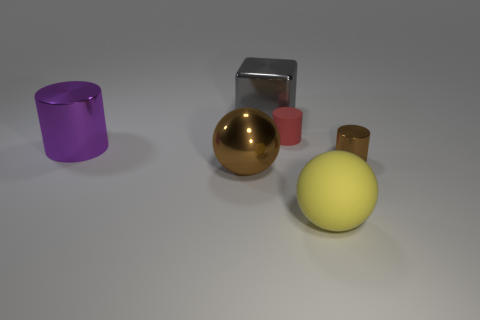There is a brown thing to the right of the big sphere on the right side of the big ball that is to the left of the gray cube; what shape is it?
Give a very brief answer. Cylinder. What material is the big purple object?
Provide a succinct answer. Metal. What is the color of the big cylinder that is made of the same material as the gray object?
Provide a succinct answer. Purple. There is a metal cylinder that is in front of the big metallic cylinder; is there a small shiny thing in front of it?
Your answer should be very brief. No. What number of other objects are the same shape as the red object?
Provide a short and direct response. 2. There is a brown thing in front of the small metallic cylinder; does it have the same shape as the brown metallic object that is on the right side of the large cube?
Provide a succinct answer. No. What number of matte spheres are in front of the matte thing that is in front of the cylinder in front of the purple thing?
Your response must be concise. 0. What is the color of the big shiny block?
Your answer should be very brief. Gray. How many other things are there of the same size as the red object?
Your response must be concise. 1. There is another purple object that is the same shape as the small metal thing; what is its material?
Provide a short and direct response. Metal. 